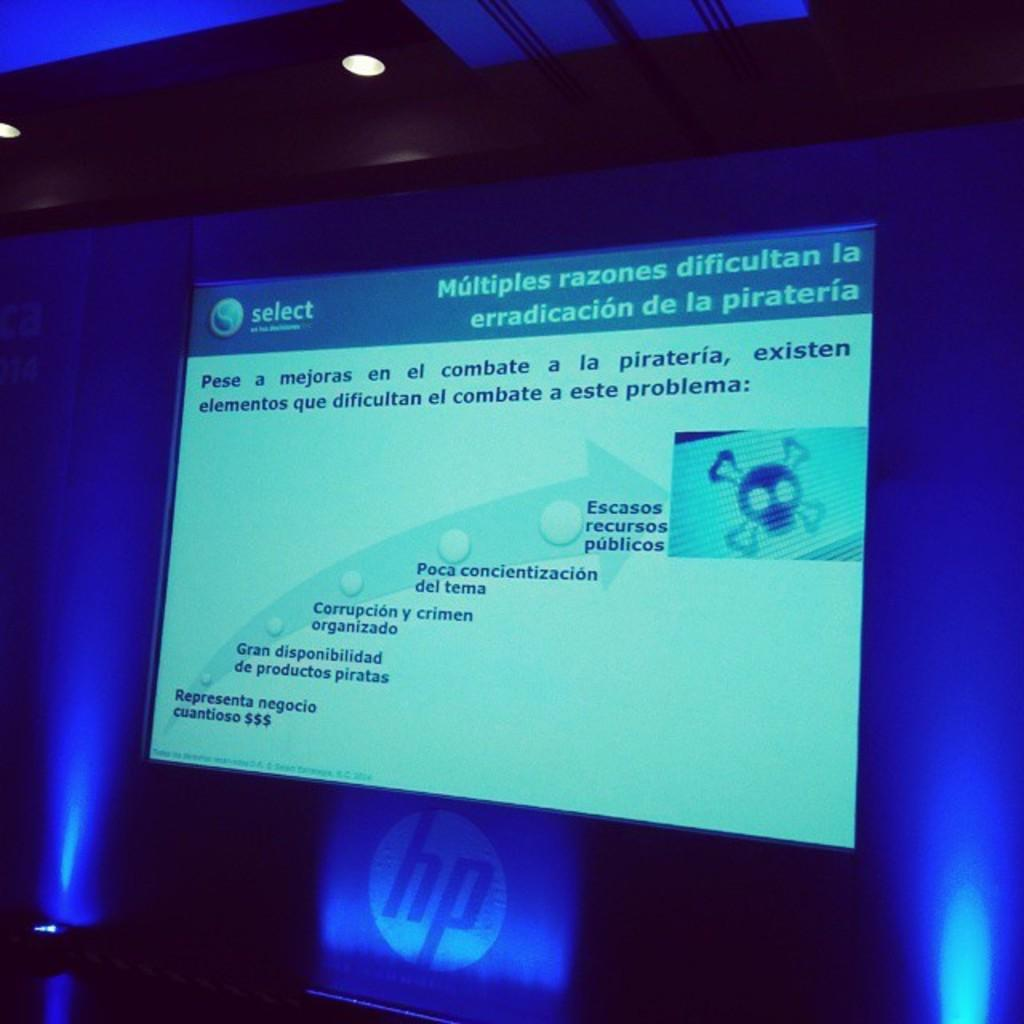<image>
Create a compact narrative representing the image presented. An HP branded screen with a window with spanish text on it that says select in the corner. 